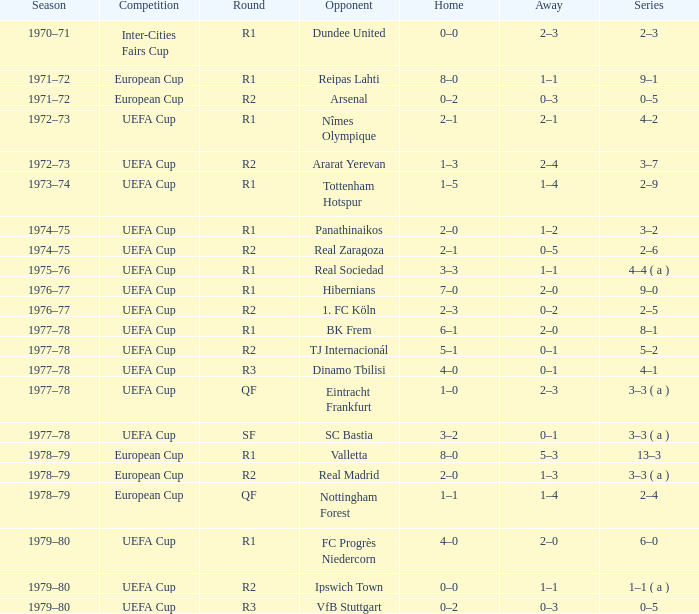Which Home has a Round of r1, and an Opponent of dundee united? 0–0. 